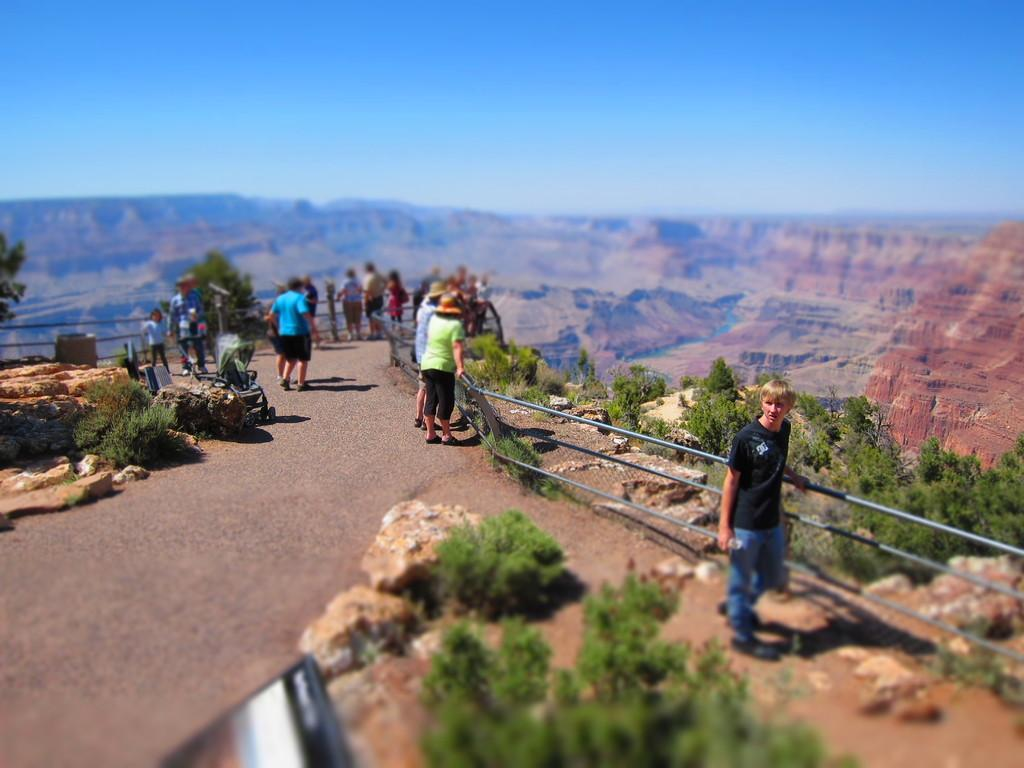What type of natural elements can be seen in the image? There are plants and rocks in the image. What man-made object is visible in the image? There is a laptop in the image. Are there any people present in the image? Yes, there are people in the image. What type of landscape feature can be seen in the image? There are hills in the image. What is visible at the top of the image? The sky is visible at the top of the image. How many stages of pain can be observed on the laptop in the image? There is no indication of pain or stages in the image, and the laptop is not a subject that can experience pain. 